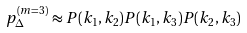Convert formula to latex. <formula><loc_0><loc_0><loc_500><loc_500>p ^ { ( m = 3 ) } _ { \Delta } \approx P ( k _ { 1 } , k _ { 2 } ) P ( k _ { 1 } , k _ { 3 } ) P ( k _ { 2 } , k _ { 3 } )</formula> 